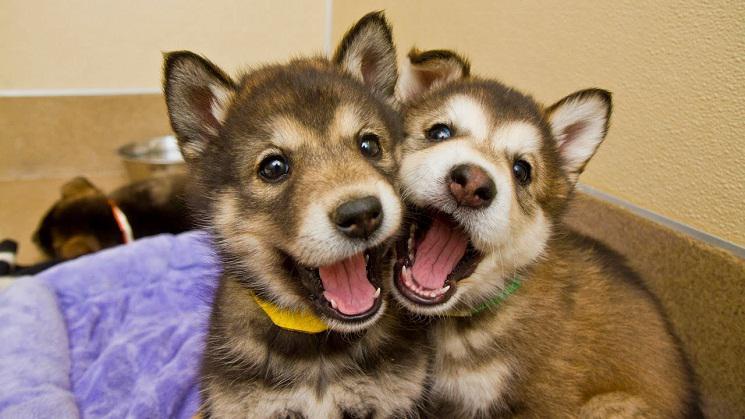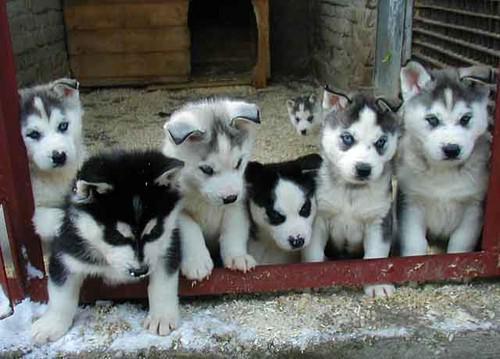The first image is the image on the left, the second image is the image on the right. Evaluate the accuracy of this statement regarding the images: "There are five grey headed husky puppies next to each other.". Is it true? Answer yes or no. Yes. The first image is the image on the left, the second image is the image on the right. Evaluate the accuracy of this statement regarding the images: "One of the images contains two dogs with their mouths open.". Is it true? Answer yes or no. Yes. 